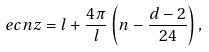Convert formula to latex. <formula><loc_0><loc_0><loc_500><loc_500>\ e c n z = l + \frac { 4 \pi } { l } \left ( n - \frac { d - 2 } { 2 4 } \right ) ,</formula> 